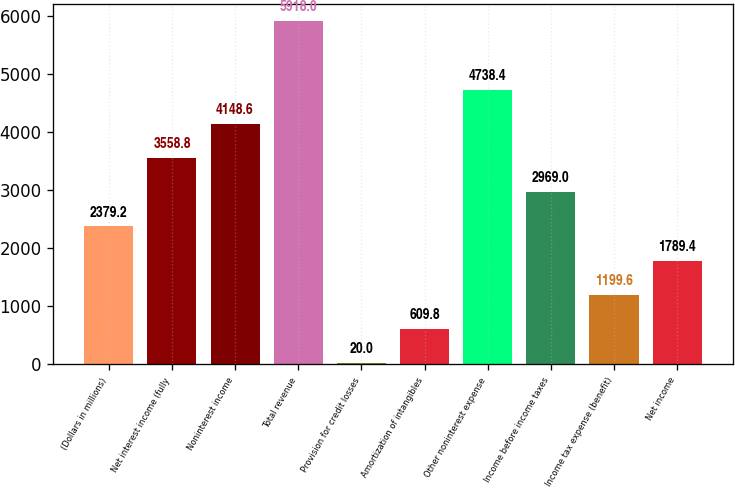Convert chart to OTSL. <chart><loc_0><loc_0><loc_500><loc_500><bar_chart><fcel>(Dollars in millions)<fcel>Net interest income (fully<fcel>Noninterest income<fcel>Total revenue<fcel>Provision for credit losses<fcel>Amortization of intangibles<fcel>Other noninterest expense<fcel>Income before income taxes<fcel>Income tax expense (benefit)<fcel>Net income<nl><fcel>2379.2<fcel>3558.8<fcel>4148.6<fcel>5918<fcel>20<fcel>609.8<fcel>4738.4<fcel>2969<fcel>1199.6<fcel>1789.4<nl></chart> 